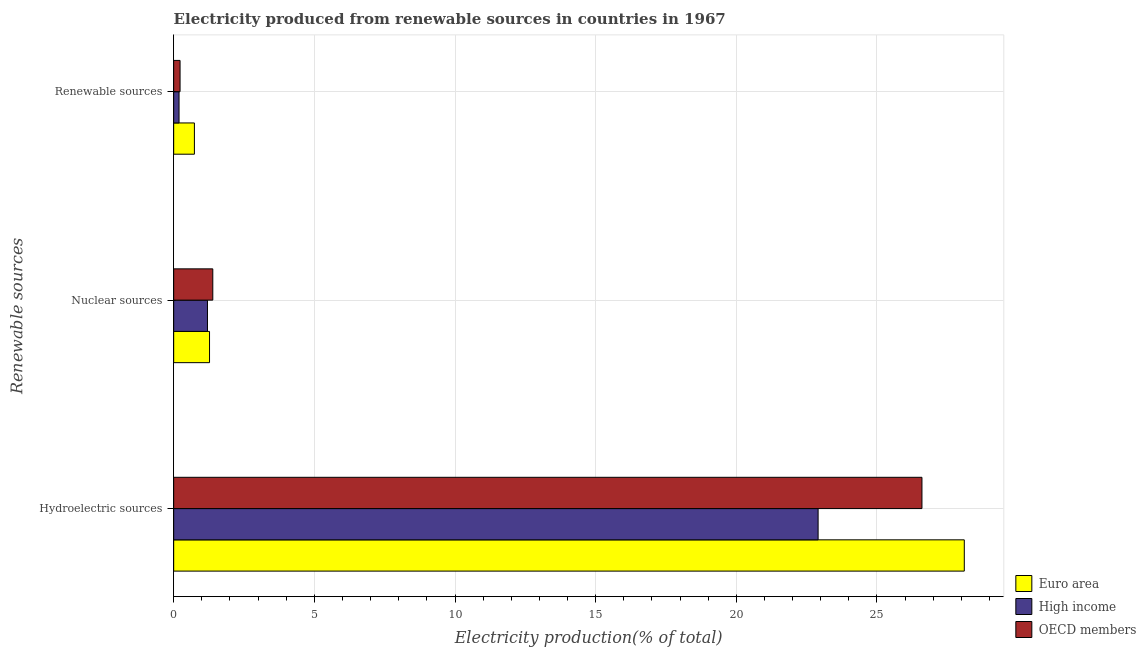How many different coloured bars are there?
Ensure brevity in your answer.  3. Are the number of bars per tick equal to the number of legend labels?
Make the answer very short. Yes. How many bars are there on the 1st tick from the bottom?
Ensure brevity in your answer.  3. What is the label of the 2nd group of bars from the top?
Offer a very short reply. Nuclear sources. What is the percentage of electricity produced by hydroelectric sources in OECD members?
Offer a very short reply. 26.6. Across all countries, what is the maximum percentage of electricity produced by hydroelectric sources?
Your answer should be compact. 28.1. Across all countries, what is the minimum percentage of electricity produced by hydroelectric sources?
Provide a succinct answer. 22.91. What is the total percentage of electricity produced by renewable sources in the graph?
Your response must be concise. 1.15. What is the difference between the percentage of electricity produced by hydroelectric sources in Euro area and that in High income?
Your answer should be very brief. 5.2. What is the difference between the percentage of electricity produced by nuclear sources in Euro area and the percentage of electricity produced by renewable sources in High income?
Provide a succinct answer. 1.08. What is the average percentage of electricity produced by nuclear sources per country?
Give a very brief answer. 1.29. What is the difference between the percentage of electricity produced by nuclear sources and percentage of electricity produced by renewable sources in High income?
Offer a terse response. 1.01. In how many countries, is the percentage of electricity produced by renewable sources greater than 17 %?
Ensure brevity in your answer.  0. What is the ratio of the percentage of electricity produced by hydroelectric sources in High income to that in OECD members?
Your response must be concise. 0.86. Is the percentage of electricity produced by hydroelectric sources in OECD members less than that in Euro area?
Your response must be concise. Yes. What is the difference between the highest and the second highest percentage of electricity produced by renewable sources?
Offer a very short reply. 0.51. What is the difference between the highest and the lowest percentage of electricity produced by hydroelectric sources?
Make the answer very short. 5.2. What does the 3rd bar from the bottom in Renewable sources represents?
Your answer should be compact. OECD members. How many bars are there?
Ensure brevity in your answer.  9. Are all the bars in the graph horizontal?
Keep it short and to the point. Yes. Are the values on the major ticks of X-axis written in scientific E-notation?
Your response must be concise. No. Does the graph contain grids?
Your answer should be very brief. Yes. Where does the legend appear in the graph?
Your answer should be very brief. Bottom right. How are the legend labels stacked?
Your answer should be very brief. Vertical. What is the title of the graph?
Ensure brevity in your answer.  Electricity produced from renewable sources in countries in 1967. What is the label or title of the Y-axis?
Your answer should be very brief. Renewable sources. What is the Electricity production(% of total) in Euro area in Hydroelectric sources?
Your answer should be very brief. 28.1. What is the Electricity production(% of total) of High income in Hydroelectric sources?
Your answer should be very brief. 22.91. What is the Electricity production(% of total) of OECD members in Hydroelectric sources?
Your response must be concise. 26.6. What is the Electricity production(% of total) in Euro area in Nuclear sources?
Your answer should be compact. 1.27. What is the Electricity production(% of total) in High income in Nuclear sources?
Make the answer very short. 1.2. What is the Electricity production(% of total) of OECD members in Nuclear sources?
Give a very brief answer. 1.39. What is the Electricity production(% of total) of Euro area in Renewable sources?
Offer a very short reply. 0.74. What is the Electricity production(% of total) of High income in Renewable sources?
Keep it short and to the point. 0.19. What is the Electricity production(% of total) in OECD members in Renewable sources?
Provide a short and direct response. 0.23. Across all Renewable sources, what is the maximum Electricity production(% of total) in Euro area?
Your response must be concise. 28.1. Across all Renewable sources, what is the maximum Electricity production(% of total) of High income?
Your answer should be compact. 22.91. Across all Renewable sources, what is the maximum Electricity production(% of total) of OECD members?
Offer a terse response. 26.6. Across all Renewable sources, what is the minimum Electricity production(% of total) of Euro area?
Keep it short and to the point. 0.74. Across all Renewable sources, what is the minimum Electricity production(% of total) of High income?
Provide a succinct answer. 0.19. Across all Renewable sources, what is the minimum Electricity production(% of total) in OECD members?
Offer a terse response. 0.23. What is the total Electricity production(% of total) in Euro area in the graph?
Your response must be concise. 30.11. What is the total Electricity production(% of total) of High income in the graph?
Ensure brevity in your answer.  24.3. What is the total Electricity production(% of total) of OECD members in the graph?
Offer a terse response. 28.22. What is the difference between the Electricity production(% of total) in Euro area in Hydroelectric sources and that in Nuclear sources?
Ensure brevity in your answer.  26.83. What is the difference between the Electricity production(% of total) of High income in Hydroelectric sources and that in Nuclear sources?
Offer a very short reply. 21.71. What is the difference between the Electricity production(% of total) in OECD members in Hydroelectric sources and that in Nuclear sources?
Your response must be concise. 25.21. What is the difference between the Electricity production(% of total) of Euro area in Hydroelectric sources and that in Renewable sources?
Make the answer very short. 27.37. What is the difference between the Electricity production(% of total) of High income in Hydroelectric sources and that in Renewable sources?
Your response must be concise. 22.72. What is the difference between the Electricity production(% of total) in OECD members in Hydroelectric sources and that in Renewable sources?
Your answer should be very brief. 26.37. What is the difference between the Electricity production(% of total) in Euro area in Nuclear sources and that in Renewable sources?
Make the answer very short. 0.54. What is the difference between the Electricity production(% of total) in High income in Nuclear sources and that in Renewable sources?
Make the answer very short. 1.01. What is the difference between the Electricity production(% of total) of OECD members in Nuclear sources and that in Renewable sources?
Offer a very short reply. 1.16. What is the difference between the Electricity production(% of total) of Euro area in Hydroelectric sources and the Electricity production(% of total) of High income in Nuclear sources?
Ensure brevity in your answer.  26.9. What is the difference between the Electricity production(% of total) of Euro area in Hydroelectric sources and the Electricity production(% of total) of OECD members in Nuclear sources?
Ensure brevity in your answer.  26.71. What is the difference between the Electricity production(% of total) in High income in Hydroelectric sources and the Electricity production(% of total) in OECD members in Nuclear sources?
Ensure brevity in your answer.  21.52. What is the difference between the Electricity production(% of total) in Euro area in Hydroelectric sources and the Electricity production(% of total) in High income in Renewable sources?
Offer a very short reply. 27.91. What is the difference between the Electricity production(% of total) in Euro area in Hydroelectric sources and the Electricity production(% of total) in OECD members in Renewable sources?
Ensure brevity in your answer.  27.88. What is the difference between the Electricity production(% of total) of High income in Hydroelectric sources and the Electricity production(% of total) of OECD members in Renewable sources?
Offer a very short reply. 22.68. What is the difference between the Electricity production(% of total) of Euro area in Nuclear sources and the Electricity production(% of total) of High income in Renewable sources?
Ensure brevity in your answer.  1.08. What is the difference between the Electricity production(% of total) of Euro area in Nuclear sources and the Electricity production(% of total) of OECD members in Renewable sources?
Offer a very short reply. 1.05. What is the difference between the Electricity production(% of total) in High income in Nuclear sources and the Electricity production(% of total) in OECD members in Renewable sources?
Keep it short and to the point. 0.97. What is the average Electricity production(% of total) in Euro area per Renewable sources?
Your response must be concise. 10.04. What is the average Electricity production(% of total) in High income per Renewable sources?
Keep it short and to the point. 8.1. What is the average Electricity production(% of total) of OECD members per Renewable sources?
Provide a short and direct response. 9.41. What is the difference between the Electricity production(% of total) of Euro area and Electricity production(% of total) of High income in Hydroelectric sources?
Offer a very short reply. 5.2. What is the difference between the Electricity production(% of total) in Euro area and Electricity production(% of total) in OECD members in Hydroelectric sources?
Provide a succinct answer. 1.5. What is the difference between the Electricity production(% of total) in High income and Electricity production(% of total) in OECD members in Hydroelectric sources?
Your response must be concise. -3.69. What is the difference between the Electricity production(% of total) of Euro area and Electricity production(% of total) of High income in Nuclear sources?
Provide a short and direct response. 0.07. What is the difference between the Electricity production(% of total) of Euro area and Electricity production(% of total) of OECD members in Nuclear sources?
Keep it short and to the point. -0.12. What is the difference between the Electricity production(% of total) of High income and Electricity production(% of total) of OECD members in Nuclear sources?
Ensure brevity in your answer.  -0.19. What is the difference between the Electricity production(% of total) in Euro area and Electricity production(% of total) in High income in Renewable sources?
Your answer should be compact. 0.55. What is the difference between the Electricity production(% of total) in Euro area and Electricity production(% of total) in OECD members in Renewable sources?
Your answer should be compact. 0.51. What is the difference between the Electricity production(% of total) in High income and Electricity production(% of total) in OECD members in Renewable sources?
Your answer should be compact. -0.04. What is the ratio of the Electricity production(% of total) of Euro area in Hydroelectric sources to that in Nuclear sources?
Keep it short and to the point. 22.05. What is the ratio of the Electricity production(% of total) in High income in Hydroelectric sources to that in Nuclear sources?
Provide a short and direct response. 19.07. What is the ratio of the Electricity production(% of total) in OECD members in Hydroelectric sources to that in Nuclear sources?
Offer a terse response. 19.13. What is the ratio of the Electricity production(% of total) in Euro area in Hydroelectric sources to that in Renewable sources?
Your response must be concise. 38.15. What is the ratio of the Electricity production(% of total) of High income in Hydroelectric sources to that in Renewable sources?
Offer a terse response. 120.03. What is the ratio of the Electricity production(% of total) of OECD members in Hydroelectric sources to that in Renewable sources?
Offer a very short reply. 117.15. What is the ratio of the Electricity production(% of total) of Euro area in Nuclear sources to that in Renewable sources?
Your answer should be very brief. 1.73. What is the ratio of the Electricity production(% of total) of High income in Nuclear sources to that in Renewable sources?
Make the answer very short. 6.3. What is the ratio of the Electricity production(% of total) in OECD members in Nuclear sources to that in Renewable sources?
Provide a succinct answer. 6.12. What is the difference between the highest and the second highest Electricity production(% of total) of Euro area?
Give a very brief answer. 26.83. What is the difference between the highest and the second highest Electricity production(% of total) in High income?
Offer a terse response. 21.71. What is the difference between the highest and the second highest Electricity production(% of total) in OECD members?
Your response must be concise. 25.21. What is the difference between the highest and the lowest Electricity production(% of total) in Euro area?
Your answer should be very brief. 27.37. What is the difference between the highest and the lowest Electricity production(% of total) in High income?
Make the answer very short. 22.72. What is the difference between the highest and the lowest Electricity production(% of total) in OECD members?
Provide a short and direct response. 26.37. 